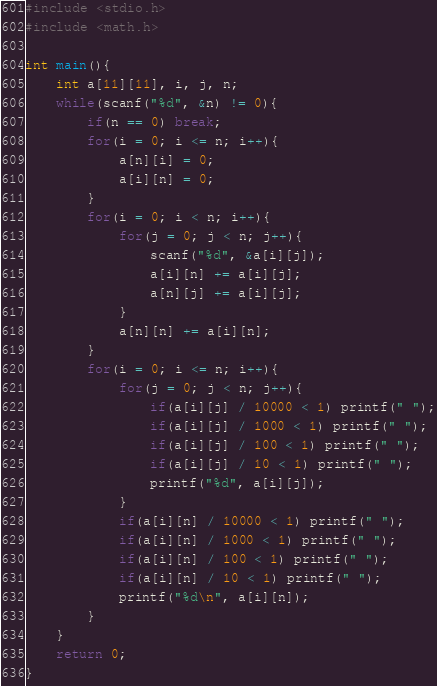<code> <loc_0><loc_0><loc_500><loc_500><_C_>#include <stdio.h>
#include <math.h>

int main(){
	int a[11][11], i, j, n;
	while(scanf("%d", &n) != 0){
		if(n == 0) break;
		for(i = 0; i <= n; i++){
			a[n][i] = 0;
			a[i][n] = 0;
		}
		for(i = 0; i < n; i++){
			for(j = 0; j < n; j++){
				scanf("%d", &a[i][j]);
				a[i][n] += a[i][j];
				a[n][j] += a[i][j];
			}
			a[n][n] += a[i][n];
		}
		for(i = 0; i <= n; i++){
			for(j = 0; j < n; j++){
				if(a[i][j] / 10000 < 1) printf(" ");
				if(a[i][j] / 1000 < 1) printf(" ");
				if(a[i][j] / 100 < 1) printf(" ");
				if(a[i][j] / 10 < 1) printf(" ");
				printf("%d", a[i][j]);
			}
			if(a[i][n] / 10000 < 1) printf(" ");
			if(a[i][n] / 1000 < 1) printf(" ");
			if(a[i][n] / 100 < 1) printf(" ");
			if(a[i][n] / 10 < 1) printf(" ");
			printf("%d\n", a[i][n]);
		}
	}
	return 0;
}</code> 